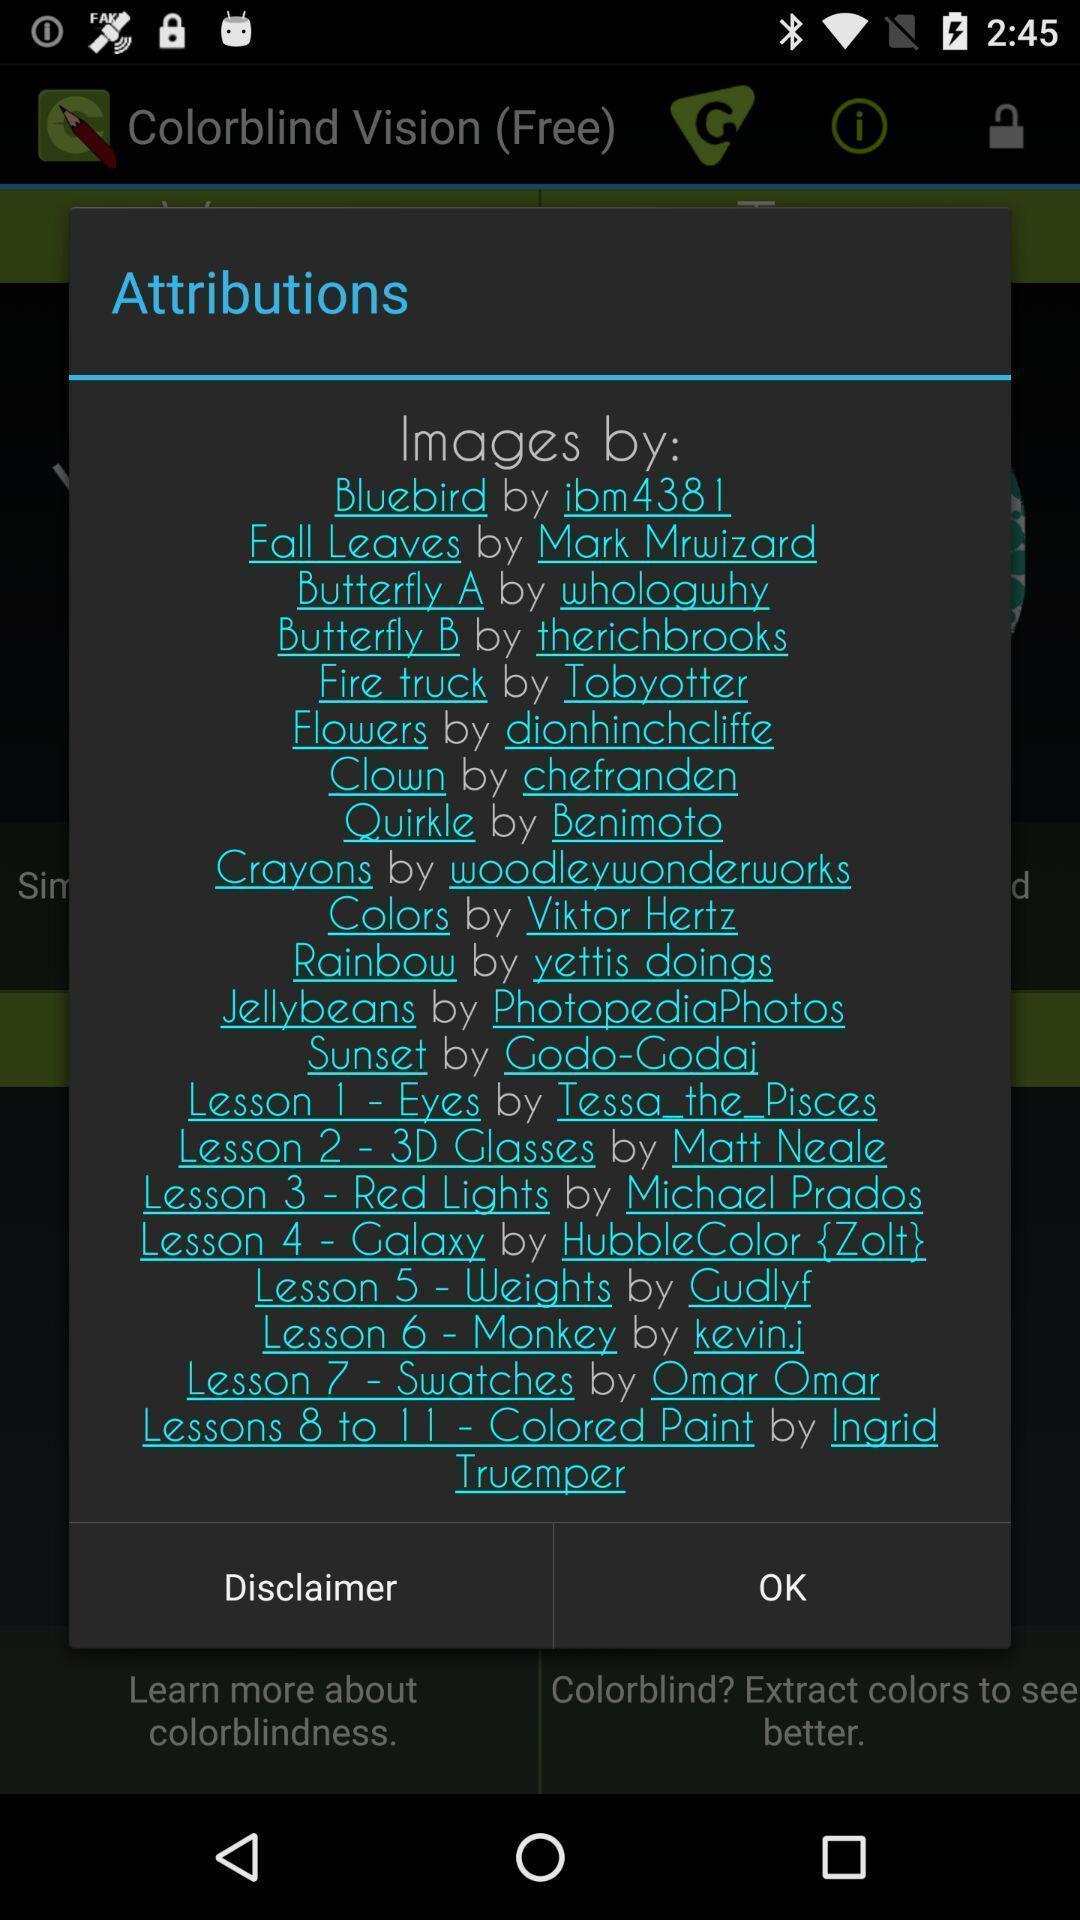Tell me about the visual elements in this screen capture. Pop-up showing list of attributions. 